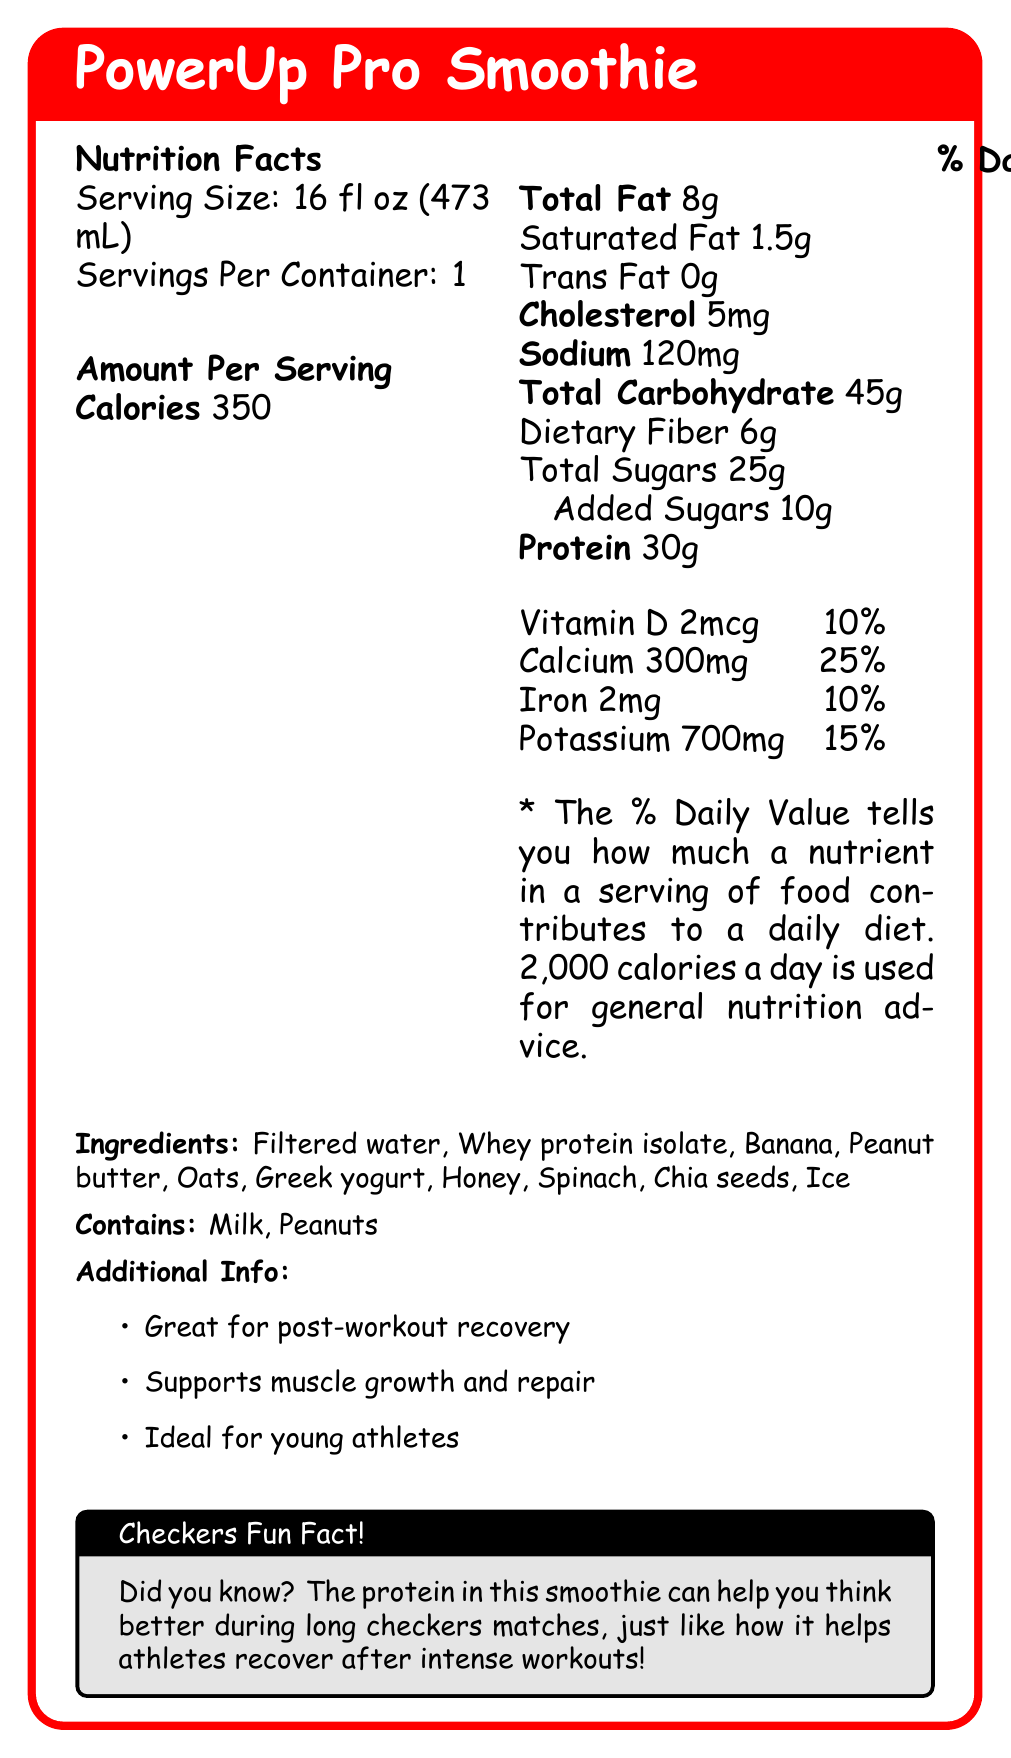what is the serving size of the PowerUp Pro Smoothie? The serving size is clearly stated as "Serving Size: 16 fl oz (473 mL)" on the Nutrition Facts label.
Answer: 16 fl oz (473 mL) how many calories are in a serving? The Nutrition Facts label states "Calories: 350" which means there are 350 calories in a serving.
Answer: 350 how much added sugars does one serving of this smoothie contain? According to the Nutrition Facts in the document, the amount of added sugars is listed as 10g.
Answer: 10g what percentage of the daily value of calcium does the PowerUp Pro Smoothie provide? The document states that one serving provides "Calcium: 300mg", which corresponds to 25% of the daily value.
Answer: 25% how much dietary fiber is in each serving? The Nutrition Facts label shows "Dietary Fiber: 6g" under the total carbohydrate section.
Answer: 6g what are the first three ingredients listed for the PowerUp Pro Smoothie? The ingredient list starts with "Filtered water," followed by "Whey protein isolate" and "Banana."
Answer: Filtered water, Whey protein isolate, Banana which vitamin is included in the Nutrition Facts label and what is its daily value percentage? The document includes "Vitamin D: 2mcg" which corresponds to 10% of the daily value.
Answer: Vitamin D, 10% what allergens are present in the PowerUp Pro Smoothie? The document states that the smoothie "Contains: Milk, Peanuts."
Answer: Milk, Peanuts why is the PowerUp Pro Smoothie recommended for young athletes? The additional info section mentions that the smoothie is "Great for post-workout recovery," "Supports muscle growth and repair," and is "Ideal for young athletes."
Answer: It supports muscle growth and repair and is ideal for post-workout recovery. Yes/No: does the PowerUp Pro Smoothie contain iron? The Nutrition Facts label includes iron with "2mg" and corresponds to 10% of the daily value.
Answer: Yes Summary: summarize the main idea of the document. The document highlights the nutritional benefits of the PowerUp Pro Smoothie, emphasizing its high protein content and other nutritional values, making it suitable for young athletes. Additionally, it lists its ingredients and allergen information.
Answer: The PowerUp Pro Smoothie is a protein-rich smoothie designed for young athletes, offering 30g of protein per serving and various nutrients such as calcium, iron, and vitamin D. It contains ingredients like whey protein isolate, banana, and peanut butter, and helps with post-workout recovery, supporting muscle growth and repair. The smoothie also includes dietary fiber and added sugars. It contains milk and peanuts as allergens. Unanswerable: what is the price of the PowerUp Pro Smoothie? The document does not provide any details about the price of the PowerUp Pro Smoothie.
Answer: Not enough information 